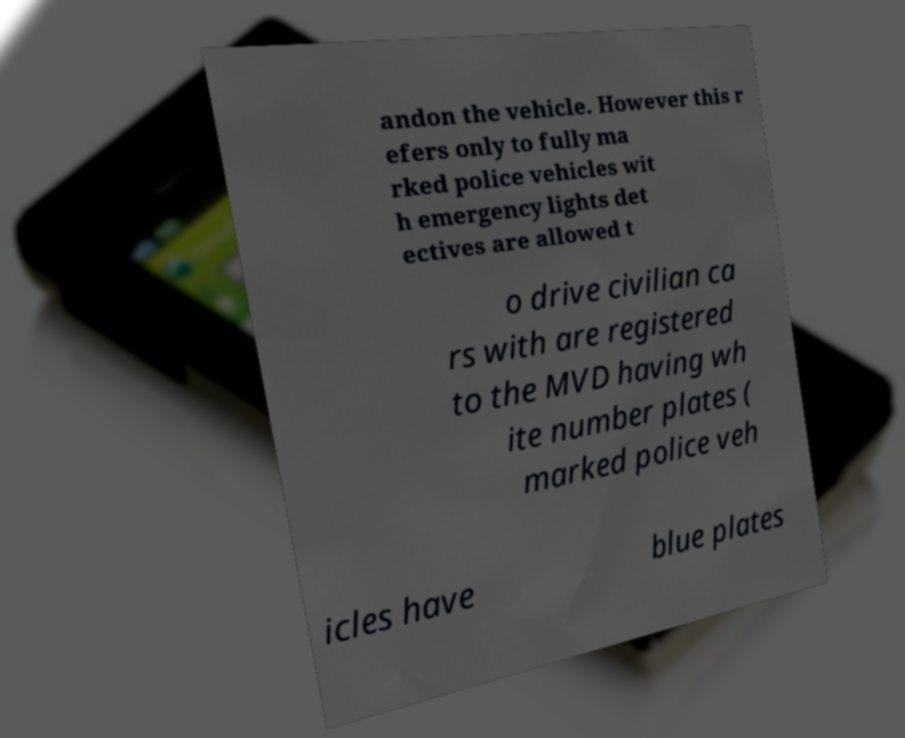Could you assist in decoding the text presented in this image and type it out clearly? andon the vehicle. However this r efers only to fully ma rked police vehicles wit h emergency lights det ectives are allowed t o drive civilian ca rs with are registered to the MVD having wh ite number plates ( marked police veh icles have blue plates 